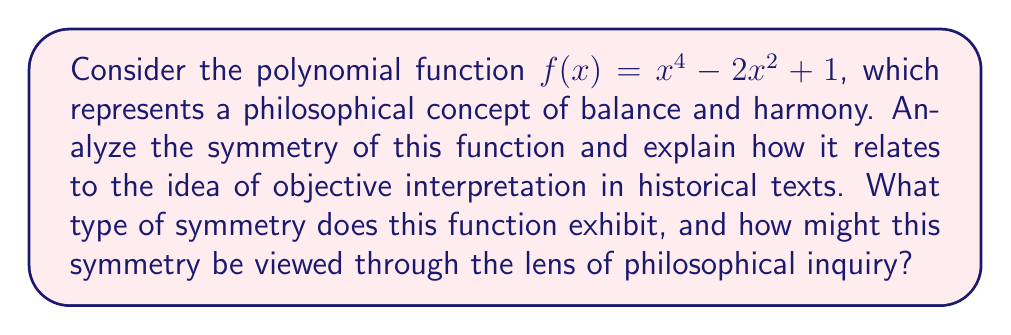Can you answer this question? To analyze the symmetry of the given polynomial function $f(x) = x^4 - 2x^2 + 1$, we need to examine its behavior when reflected across different axes:

1. Symmetry about the y-axis:
   Let's check if $f(x) = f(-x)$ for all $x$:
   $f(-x) = (-x)^4 - 2(-x)^2 + 1 = x^4 - 2x^2 + 1 = f(x)$
   This equality holds, indicating that the function is symmetric about the y-axis.

2. Symmetry about the x-axis:
   The function is not symmetric about the x-axis because $f(x) \neq -f(x)$ for all $x$.

3. Origin symmetry:
   The function is not symmetric about the origin because $f(-x) \neq -f(x)$ for all $x$.

The function exhibits even symmetry, which means it is symmetric about the y-axis. This can be visualized as a perfect reflection of the graph across the y-axis.

[asy]
import graph;
size(200,200);
real f(real x) {return x^4 - 2x^2 + 1;}
draw(graph(f,-2,2),blue);
draw((-2,0)--(2,0),arrow=Arrow(TeXHead));
draw((0,-1)--(0,3),arrow=Arrow(TeXHead));
label("x",(2,0),E);
label("y",(0,3),N);
[/asy]

From a philosophical perspective, this symmetry can be interpreted as a representation of balance and harmony. The even symmetry suggests a perfect equilibrium between positive and negative values, which could be seen as analogous to the balance sought in philosophical inquiries.

In the context of interpreting historical texts within faith, this symmetry might be viewed as a metaphor for the challenge of maintaining objectivity. Just as the function maintains perfect balance around the y-axis, a philosopher might strive for a balanced interpretation of texts, considering both positive and negative aspects equally.

However, the limitations of this symmetry (only about the y-axis) could also represent the inherent difficulties in achieving true objectivity. While we may strive for balance, our interpretations might still be centered around a particular axis (in this case, the y-axis), which could represent our own biases or preconceptions.

The fact that the function is not symmetric about the x-axis or the origin could be seen as a reminder that perfect objectivity in all dimensions may be unattainable, and that our interpretations will always be influenced by our position relative to the subject matter.
Answer: The polynomial function $f(x) = x^4 - 2x^2 + 1$ exhibits even symmetry (symmetry about the y-axis). This symmetry can be interpreted as a representation of balance in philosophical inquiry, while also highlighting the challenges of achieving complete objectivity in interpreting historical texts within the context of faith. 